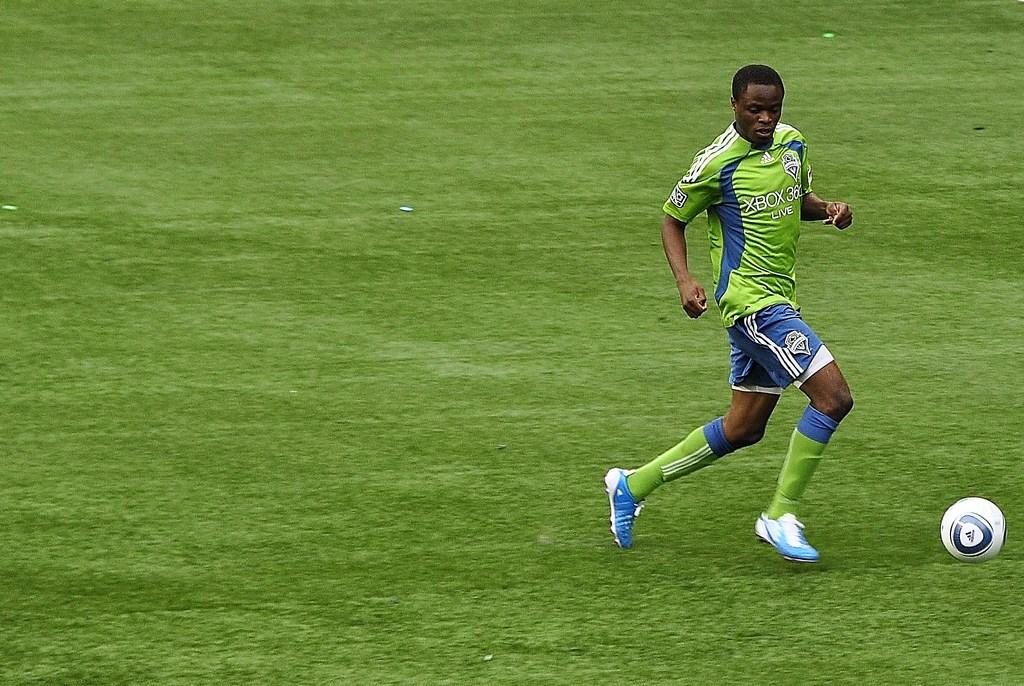<image>
Render a clear and concise summary of the photo. A soccer player in a shirt that says Xbox 360 kicks a ball. 